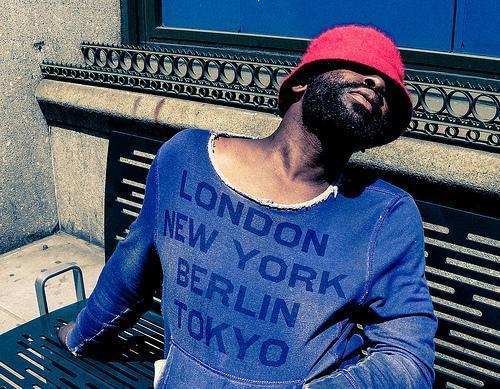How many men are sitting on the bench?
Give a very brief answer. 1. How many cities are listed on the man's shirt?
Give a very brief answer. 4. 